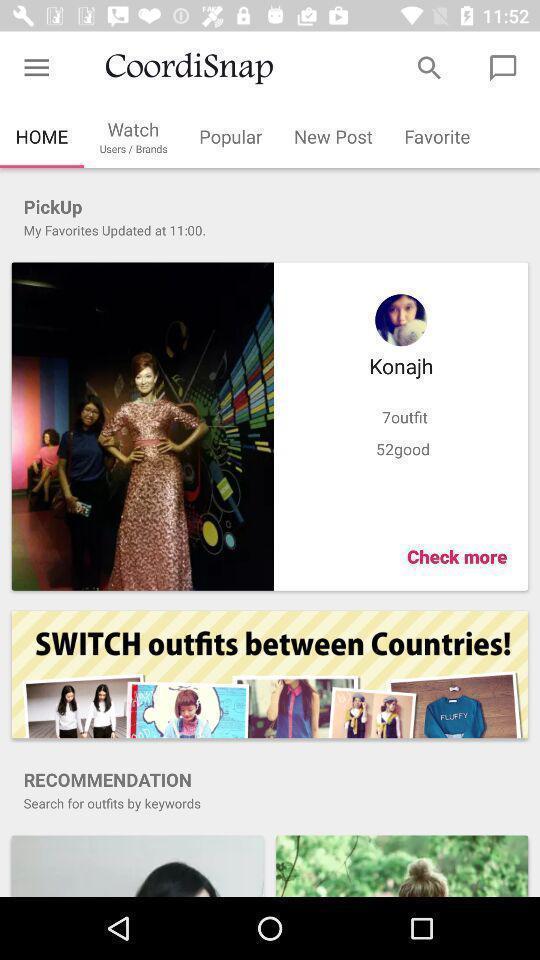Explain what's happening in this screen capture. Screen showing home page. 